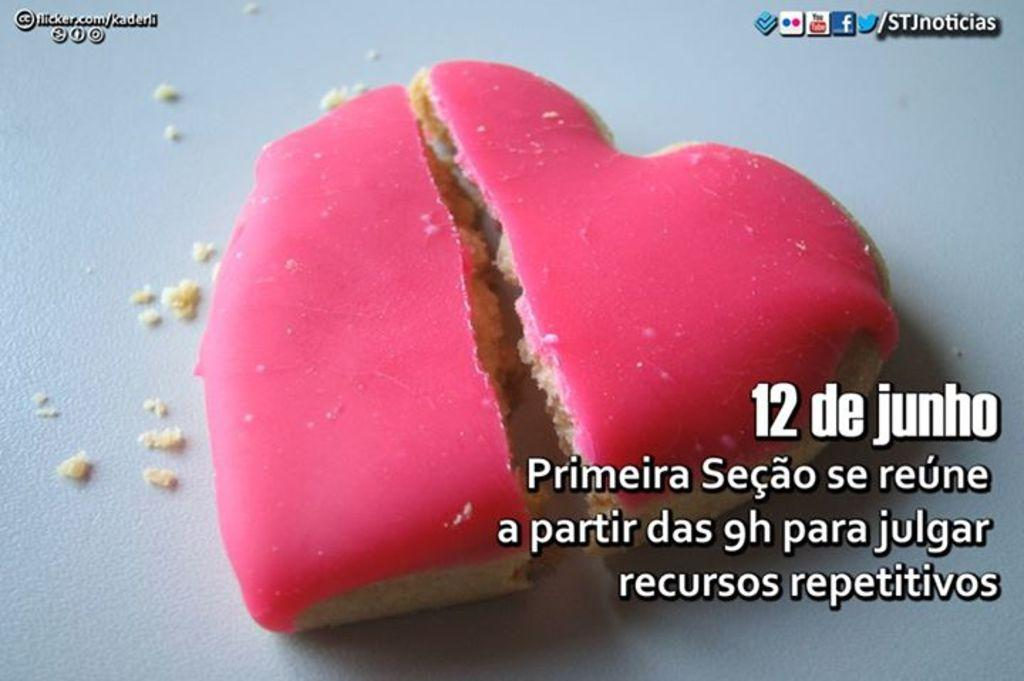What type of item is present in the image? There is an edible item in the image. What color is the edible item? The edible item is pink in color. Is there any text present in the image? Yes, there is text written in the right corner of the image. How far away is the grape from the edible item in the image? There is no grape present in the image, so it cannot be determined how far away it might be from the edible item. 